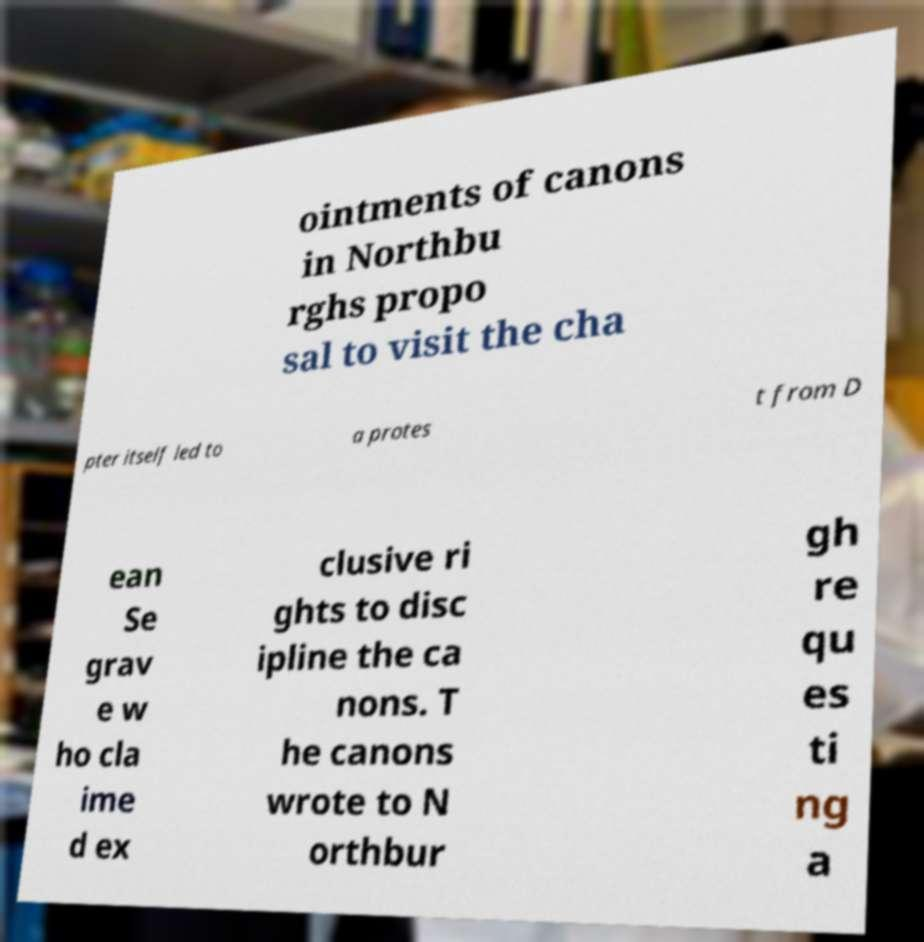I need the written content from this picture converted into text. Can you do that? ointments of canons in Northbu rghs propo sal to visit the cha pter itself led to a protes t from D ean Se grav e w ho cla ime d ex clusive ri ghts to disc ipline the ca nons. T he canons wrote to N orthbur gh re qu es ti ng a 